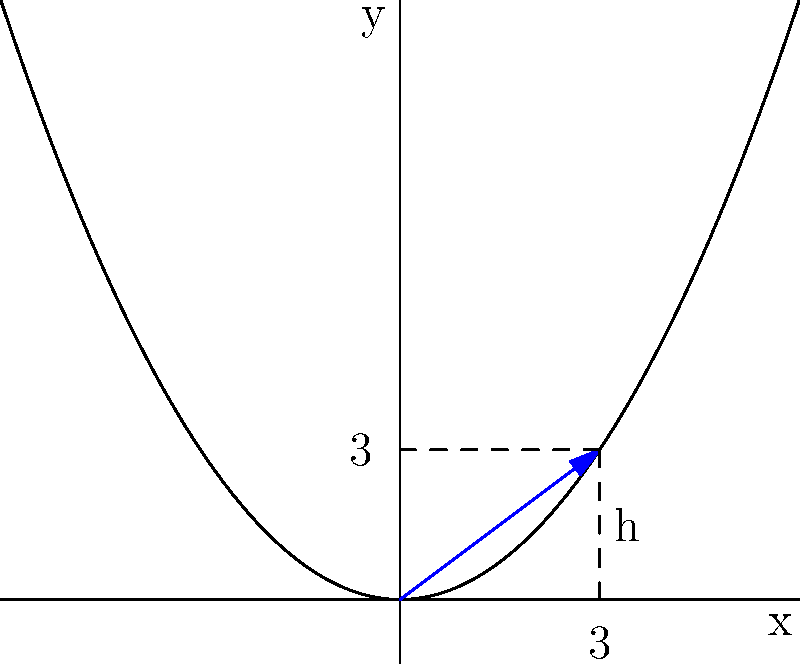A luxury furniture manufacturer is designing a curved metal coffee table base using a parabolic shape. The base is modeled by the equation $y = 0.25x^2$, where x and y are measured in feet. If the width of the base is 6 feet, what is the height (h) of the curve at the edge of the table? To solve this problem, we'll follow these steps:

1) The equation of the parabola is $y = 0.25x^2$

2) The width of the base is 6 feet, which means it extends 3 feet on each side of the y-axis. We need to find the height at $x = 3$

3) To find the height, we substitute $x = 3$ into the equation:

   $y = 0.25(3)^2$

4) Simplify:
   $y = 0.25 * 9 = 2.25$

5) Therefore, the height of the curve at the edge of the table (at $x = 3$) is 2.25 feet.
Answer: 2.25 feet 